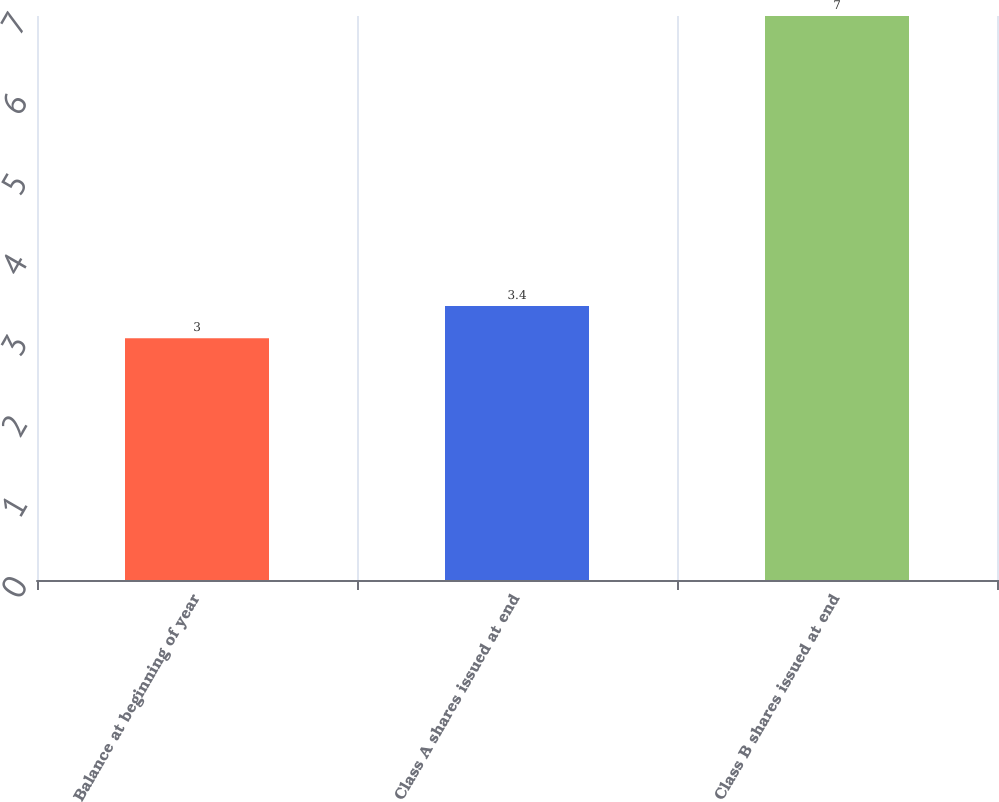Convert chart to OTSL. <chart><loc_0><loc_0><loc_500><loc_500><bar_chart><fcel>Balance at beginning of year<fcel>Class A shares issued at end<fcel>Class B shares issued at end<nl><fcel>3<fcel>3.4<fcel>7<nl></chart> 